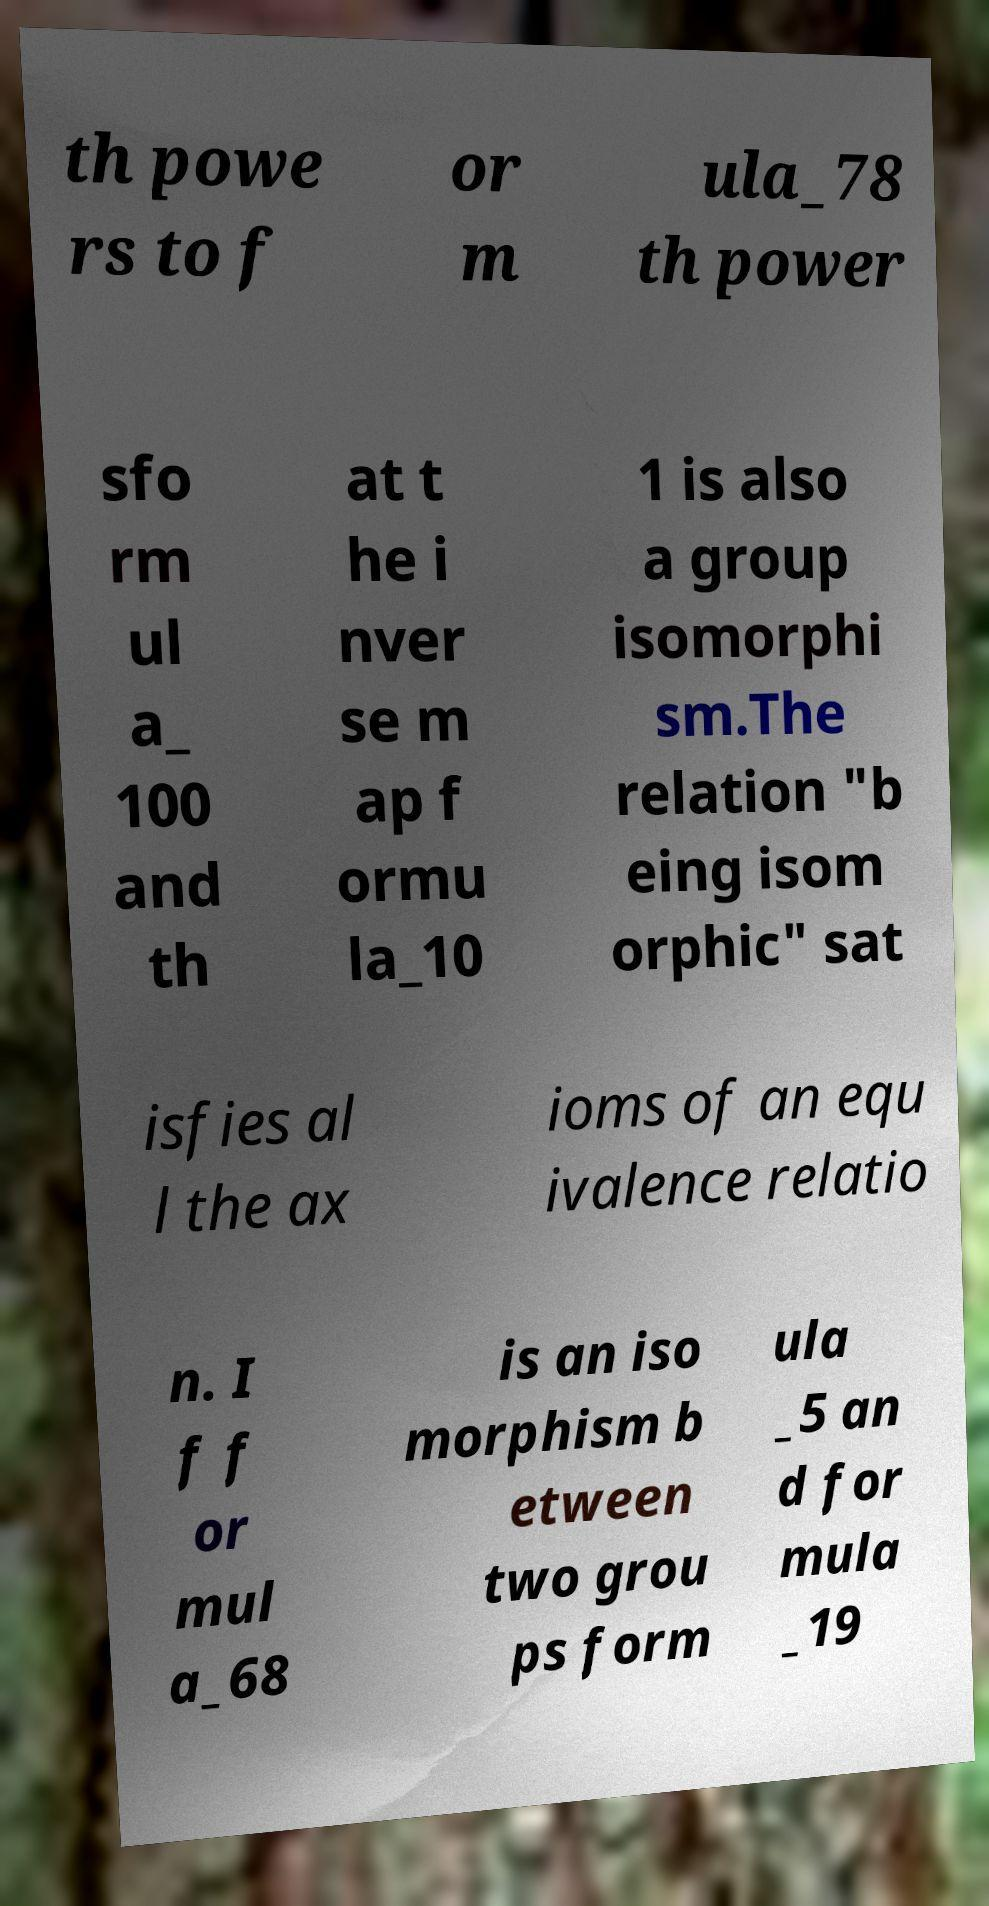Please identify and transcribe the text found in this image. th powe rs to f or m ula_78 th power sfo rm ul a_ 100 and th at t he i nver se m ap f ormu la_10 1 is also a group isomorphi sm.The relation "b eing isom orphic" sat isfies al l the ax ioms of an equ ivalence relatio n. I f f or mul a_68 is an iso morphism b etween two grou ps form ula _5 an d for mula _19 